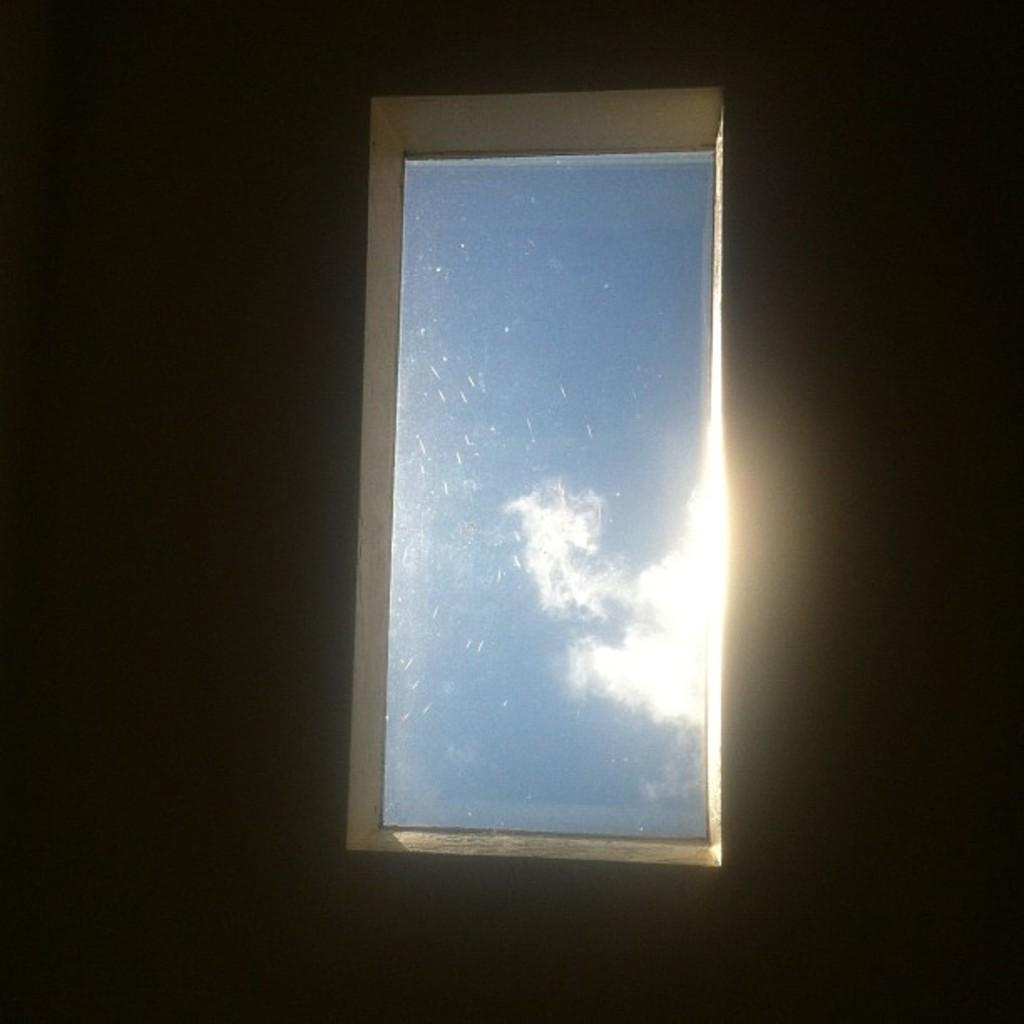Could you give a brief overview of what you see in this image? This picture seems to be clicked inside. In the center there is a window and through the window we can see the sky and some clouds. The background of the image is very dark. 